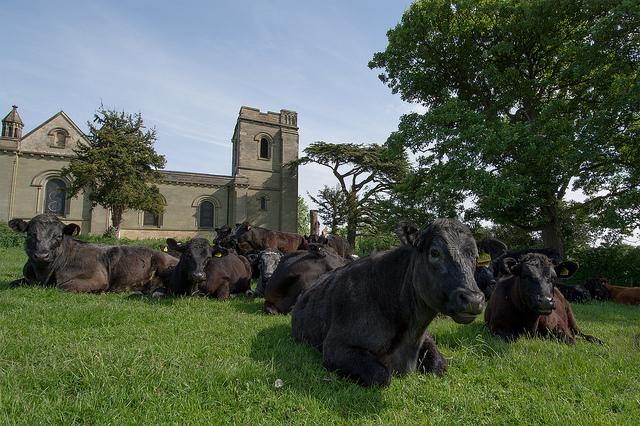Are the cows walking in the field?
Be succinct. No. Why are they lying down?
Answer briefly. Tired. What type of animal?
Be succinct. Cow. 